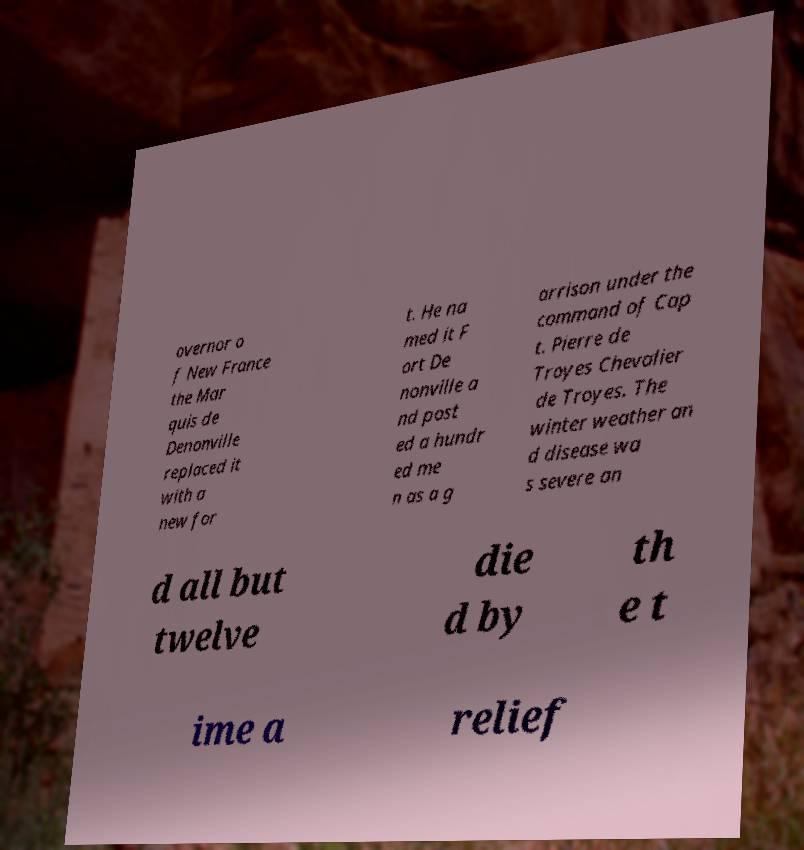What messages or text are displayed in this image? I need them in a readable, typed format. overnor o f New France the Mar quis de Denonville replaced it with a new for t. He na med it F ort De nonville a nd post ed a hundr ed me n as a g arrison under the command of Cap t. Pierre de Troyes Chevalier de Troyes. The winter weather an d disease wa s severe an d all but twelve die d by th e t ime a relief 